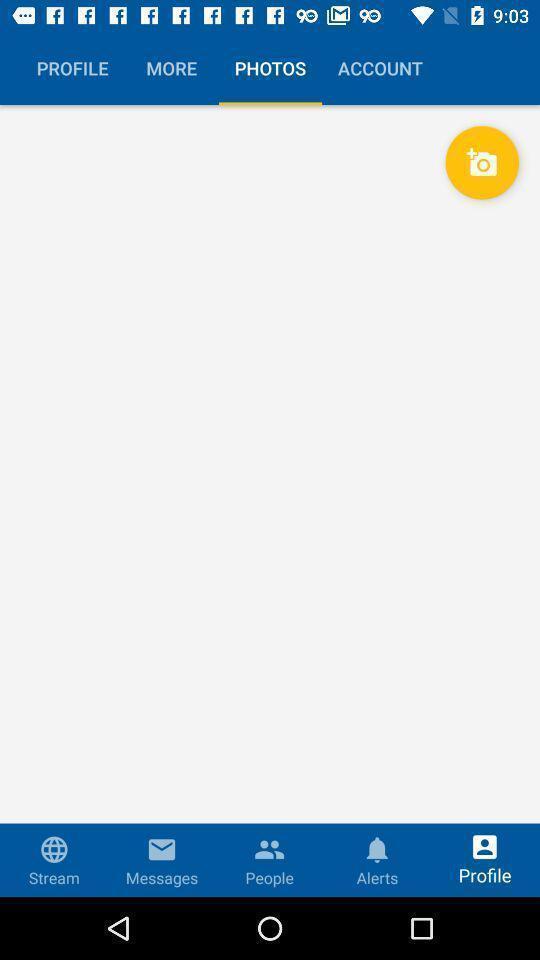Describe the visual elements of this screenshot. Page showing your photos in the social app. 